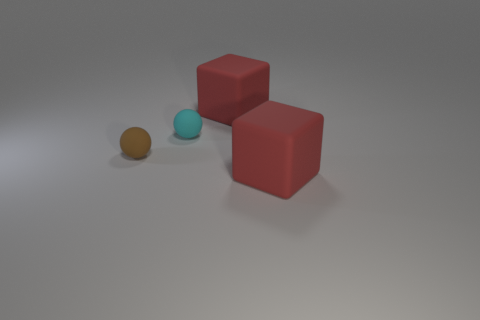There is a red thing that is on the right side of the big red thing that is left of the big rubber block in front of the small cyan matte thing; what is its material?
Your answer should be compact. Rubber. What number of red things are big cylinders or small spheres?
Keep it short and to the point. 0. How big is the brown ball that is to the left of the large red block that is behind the cyan matte sphere that is behind the small brown matte thing?
Make the answer very short. Small. There is another rubber object that is the same shape as the cyan thing; what size is it?
Your answer should be very brief. Small. How many big objects are red matte things or brown rubber objects?
Ensure brevity in your answer.  2. Are the sphere in front of the cyan rubber thing and the large red cube that is in front of the cyan rubber ball made of the same material?
Provide a succinct answer. Yes. What is the red object that is behind the brown matte sphere made of?
Your answer should be very brief. Rubber. How many shiny objects are tiny green cubes or brown balls?
Make the answer very short. 0. There is a rubber thing in front of the rubber ball that is left of the small cyan sphere; what is its color?
Make the answer very short. Red. Does the tiny cyan ball have the same material as the ball to the left of the cyan matte ball?
Give a very brief answer. Yes. 